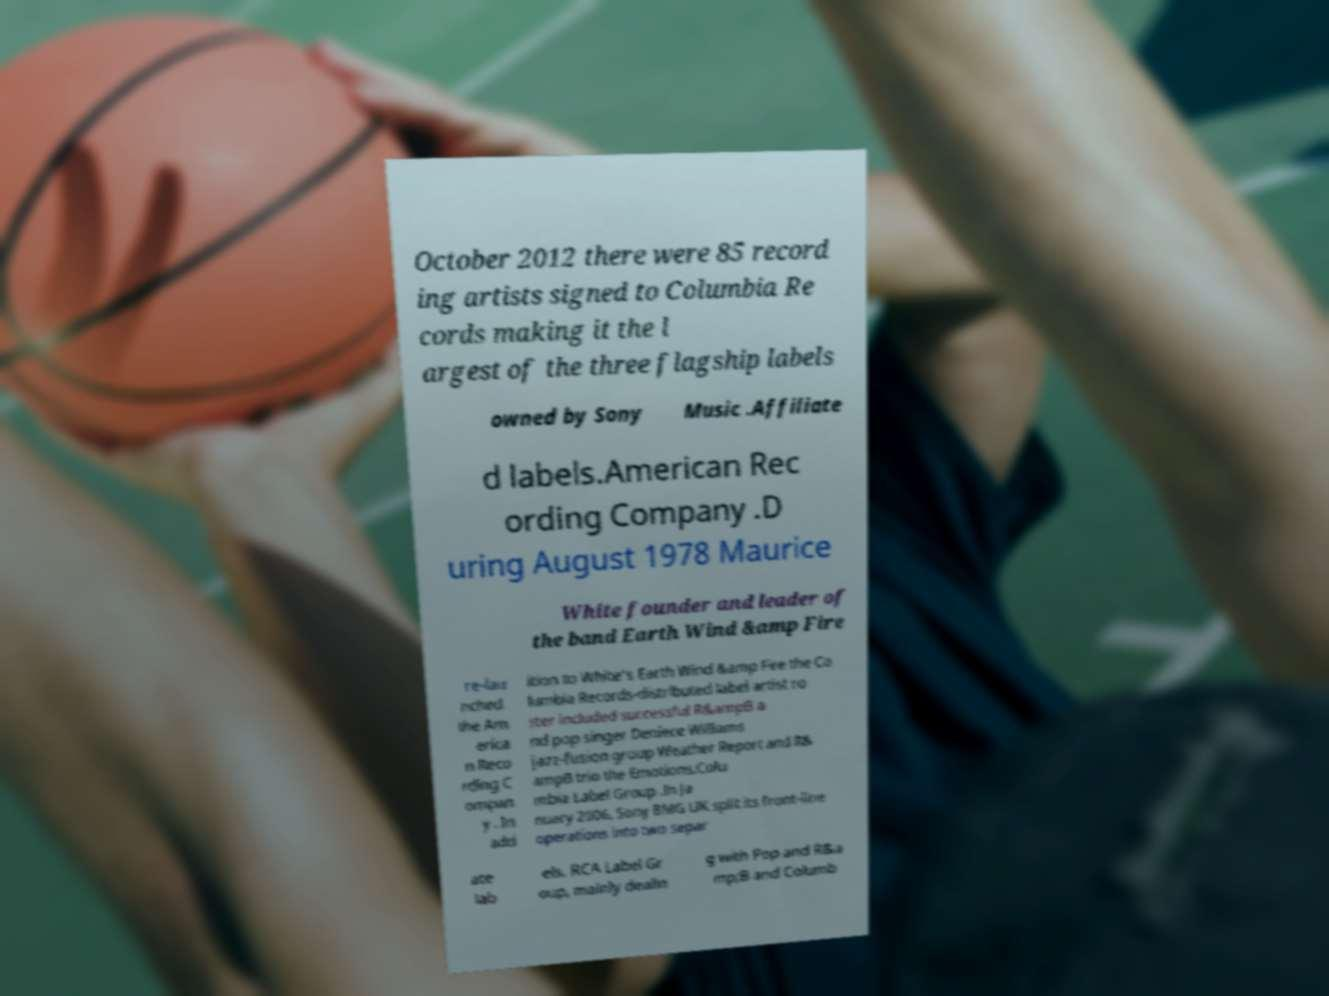Please identify and transcribe the text found in this image. October 2012 there were 85 record ing artists signed to Columbia Re cords making it the l argest of the three flagship labels owned by Sony Music .Affiliate d labels.American Rec ording Company .D uring August 1978 Maurice White founder and leader of the band Earth Wind &amp Fire re-lau nched the Am erica n Reco rding C ompan y . In add ition to White's Earth Wind &amp Fire the Co lumbia Records-distributed label artist ro ster included successful R&ampB a nd pop singer Deniece Williams jazz-fusion group Weather Report and R& ampB trio the Emotions.Colu mbia Label Group .In Ja nuary 2006, Sony BMG UK split its front-line operations into two separ ate lab els. RCA Label Gr oup, mainly dealin g with Pop and R&a mp;B and Columb 